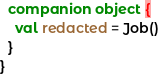<code> <loc_0><loc_0><loc_500><loc_500><_Kotlin_>
  companion object {
    val redacted = Job()
  }
}
</code> 